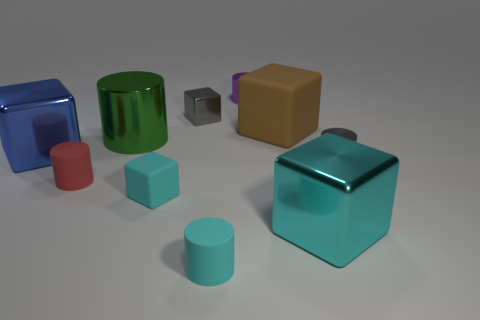There is a metallic thing that is the same color as the tiny rubber cube; what size is it?
Make the answer very short. Large. How many objects are matte things behind the blue cube or large metal objects behind the red rubber cylinder?
Offer a very short reply. 3. Are there fewer big objects than large brown matte things?
Your answer should be compact. No. There is a green cylinder that is the same size as the blue block; what is its material?
Keep it short and to the point. Metal. Is the size of the gray thing to the right of the brown thing the same as the matte thing on the right side of the small purple thing?
Provide a short and direct response. No. Are there any things made of the same material as the small cyan cylinder?
Offer a very short reply. Yes. How many things are either metallic cubes right of the big brown block or big purple things?
Ensure brevity in your answer.  1. Do the cylinder that is in front of the large cyan object and the purple object have the same material?
Your answer should be very brief. No. Does the large brown thing have the same shape as the purple object?
Offer a very short reply. No. What number of large shiny blocks are in front of the tiny gray metal thing that is right of the large matte object?
Give a very brief answer. 1. 